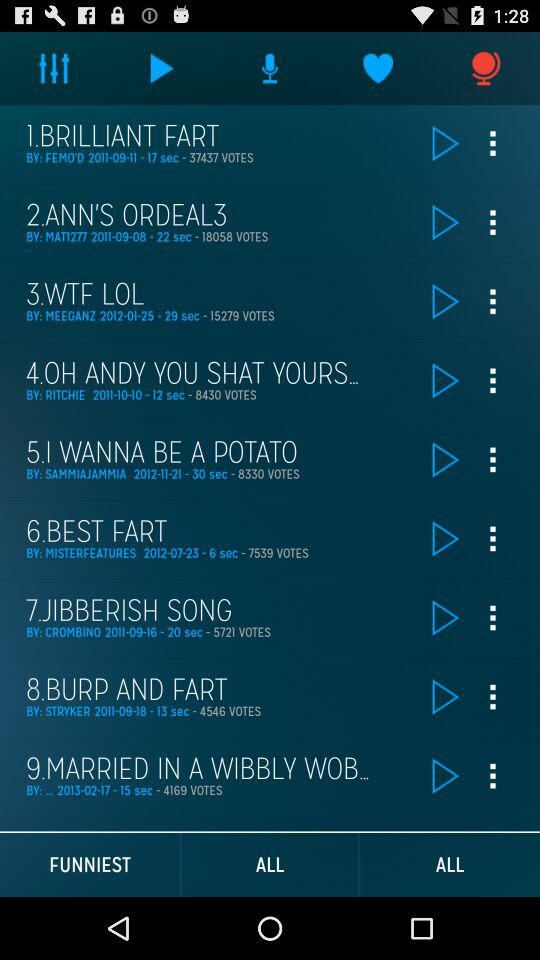What is the number of votes for the "WTF LOL"? The number of votes are 15279. 